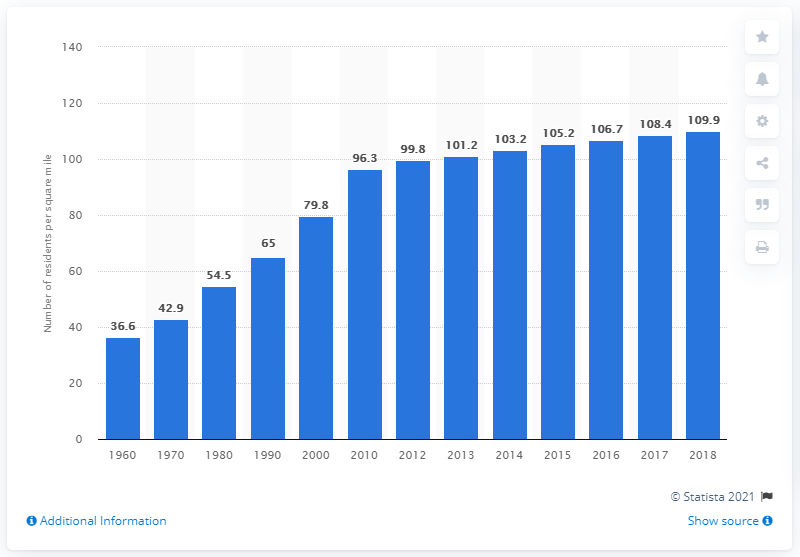Identify some key points in this picture. In 2018, the population density of Texas was 109.9 people per square mile. 